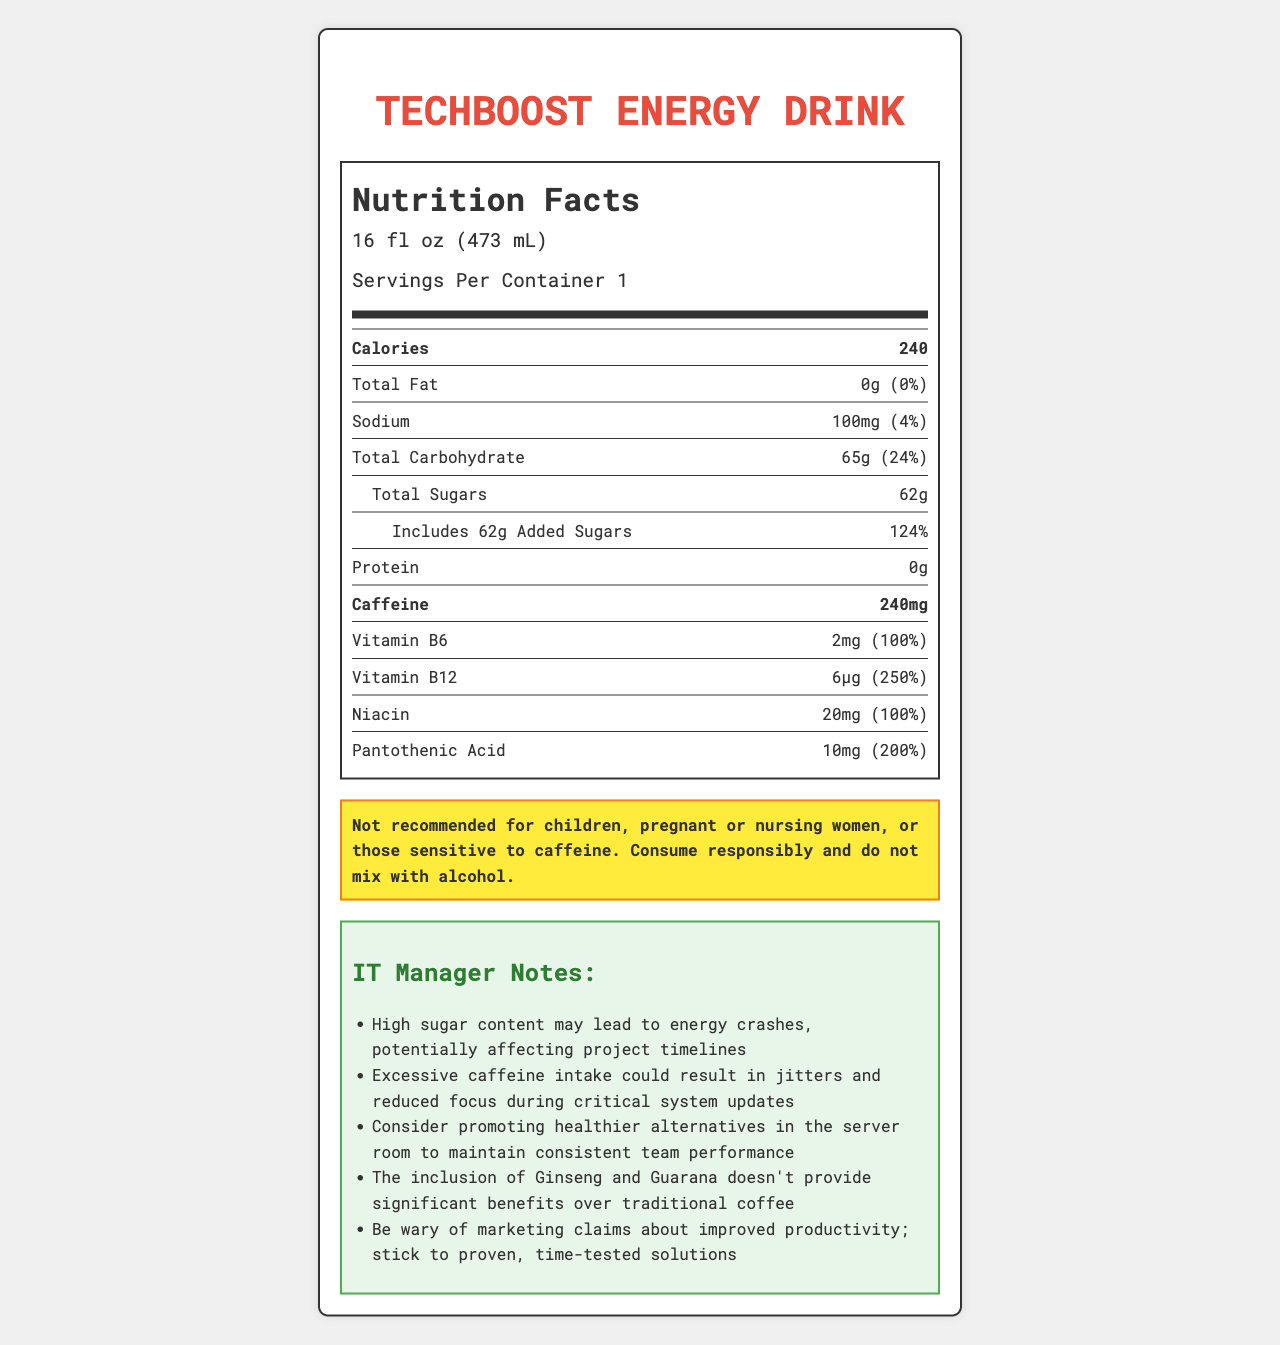what is the serving size of TechBoost Energy Drink? The serving size is mentioned directly under the drink's name and heading "Nutrition Facts".
Answer: 16 fl oz (473 mL) How much caffeine is in a single serving? The amount of caffeine is listed explicitly under the nutrient information.
Answer: 240mg What is the total amount of sugars in the TechBoost Energy Drink? Under the Total Sugars section, it is mentioned that the drink contains 62g of sugar.
Answer: 62g How much added sugar does the TechBoost Energy Drink contain? It is clarified within the Total Sugars subsection that 62g is added sugars.
Answer: 62g What percentage of the daily value for Vitamin B12 does a serving provide? The daily value percentage for Vitamin B12 is listed under the vitamins and minerals segment.
Answer: 250% Which of the following ingredients is NOT listed in TechBoost Energy Drink? A. Sodium Citrate B. Guarana Seed Extract C. Ascorbic Acid D. Sucralose Ascorbic Acid is not listed among the ingredients of the TechBoost Energy Drink.
Answer: C What part of the label warns against caffeine sensitivity? A. Allergen Info B. Manufacturer Information C. Warning Section D. Notes Section The warning about caffeine sensitivity is mentioned in the "Warning" section at the bottom of the label.
Answer: C Is this product recommended for children? The warning clearly states that the product is "Not recommended for children".
Answer: No Summarize the main points of the nutrition label for TechBoost Energy Drink. The summary outlines the serving size, key nutritional content, and relevant warnings and notes from the label.
Answer: TechBoost Energy Drink offers a single serving of 16 fl oz with high caffeine (240mg) and substantial sugar (62g) content, providing 240 calories. It contains no fats or proteins but includes Vitamin B6, B12, Niacin, and Pantothenic Acid. The drink is manufactured by LegacyTech Beverages and carries warnings regarding its caffeine content and suitability for certain populations. What are the potential impacts of high sugar content on project timelines, according to the IT manager notes? This note is specifically mentioned in the IT manager notes section, highlighting concerns about high sugar content.
Answer: Energy crashes may potentially affect project timelines. What is recommended for consistent team performance according to the IT manager notes? This recommendation is part of the IT manager notes aiming to maintain consistent performance.
Answer: Promoting healthier alternatives in the server room. What does the label suggest doing with the bottle after consuming the drink? The recycling information at the bottom of the label suggests recycling the bottle.
Answer: Please recycle Where is the product manufactured? The label does not provide specific location details about the manufacturing of the product, only mentioning the manufacturer.
Answer: Not enough information What added ingredient in the drink might be appealing for cognitive function claims? The IT manager notes reference these ingredients, and they are both listed in the ingredients list.
Answer: Ginseng and Guarana What should be done with the TechBoost Energy Drink after opening it? The "storage" section at the bottom of the label provides this information.
Answer: Refrigerate after opening 